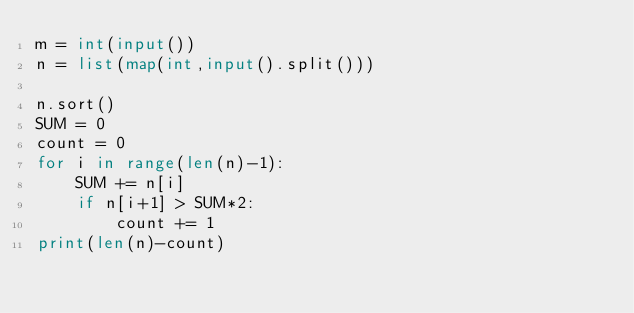Convert code to text. <code><loc_0><loc_0><loc_500><loc_500><_Python_>m = int(input())
n = list(map(int,input().split()))

n.sort()
SUM = 0
count = 0
for i in range(len(n)-1):
    SUM += n[i]
    if n[i+1] > SUM*2:
        count += 1
print(len(n)-count)
    

</code> 